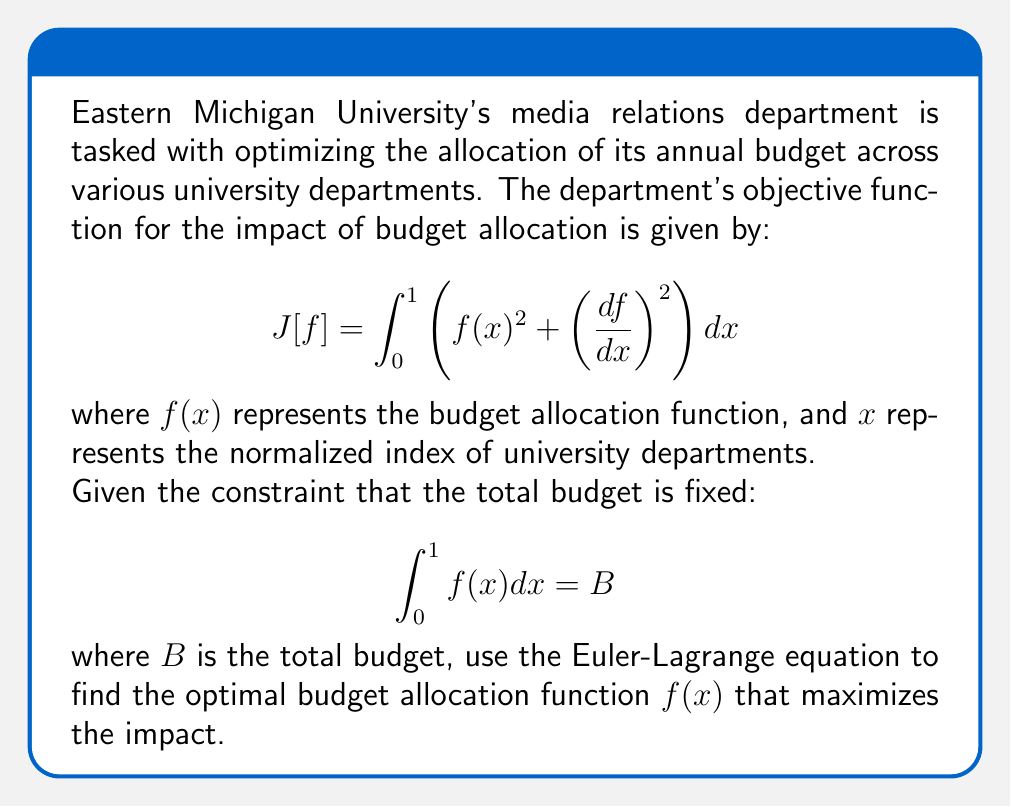Solve this math problem. To solve this optimization problem with a constraint, we'll use the method of Lagrange multipliers and the Euler-Lagrange equation.

Step 1: Form the augmented functional
We introduce a Lagrange multiplier $\lambda$ and form the augmented functional:
$$J^*[f] = \int_0^1 \left(f(x)^2 + \left(\frac{df}{dx}\right)^2 + \lambda f(x)\right) dx - \lambda B$$

Step 2: Apply the Euler-Lagrange equation
The Euler-Lagrange equation is:
$$\frac{\partial L}{\partial f} - \frac{d}{dx}\left(\frac{\partial L}{\partial f'}\right) = 0$$
where $L = f(x)^2 + (f'(x))^2 + \lambda f(x)$ is the integrand of $J^*[f]$.

Step 3: Calculate the partial derivatives
$$\frac{\partial L}{\partial f} = 2f + \lambda$$
$$\frac{\partial L}{\partial f'} = 2f'$$

Step 4: Substitute into the Euler-Lagrange equation
$$2f + \lambda - \frac{d}{dx}(2f') = 0$$
$$2f + \lambda - 2f'' = 0$$

Step 5: Rearrange the equation
$$f'' - f = \frac{\lambda}{2}$$

Step 6: Solve the differential equation
The general solution to this equation is:
$$f(x) = Ae^x + Be^{-x} - \frac{\lambda}{2}$$
where $A$ and $B$ are constants to be determined.

Step 7: Apply boundary conditions
Since we don't have specific boundary conditions, we can use the symmetry of the problem to assume that $f(0) = f(1)$. This gives us:
$$A + B - \frac{\lambda}{2} = Ae + Be^{-1} - \frac{\lambda}{2}$$

Step 8: Apply the constraint
$$\int_0^1 f(x) dx = B$$
$$\int_0^1 (Ae^x + Be^{-x} - \frac{\lambda}{2}) dx = B$$
$$A(e-1) + B(1-e^{-1}) - \frac{\lambda}{2} = B$$

Step 9: Solve for $A$, $B$, and $\lambda$
From the symmetry condition and the constraint, we can solve for $A$, $B$, and $\lambda$. The exact values depend on the total budget $B$.

Therefore, the optimal budget allocation function is of the form:
$$f(x) = Ae^x + Be^{-x} - \frac{\lambda}{2}$$
where $A$, $B$, and $\lambda$ are constants determined by the total budget and symmetry conditions.
Answer: $f(x) = Ae^x + Be^{-x} - \frac{\lambda}{2}$ 